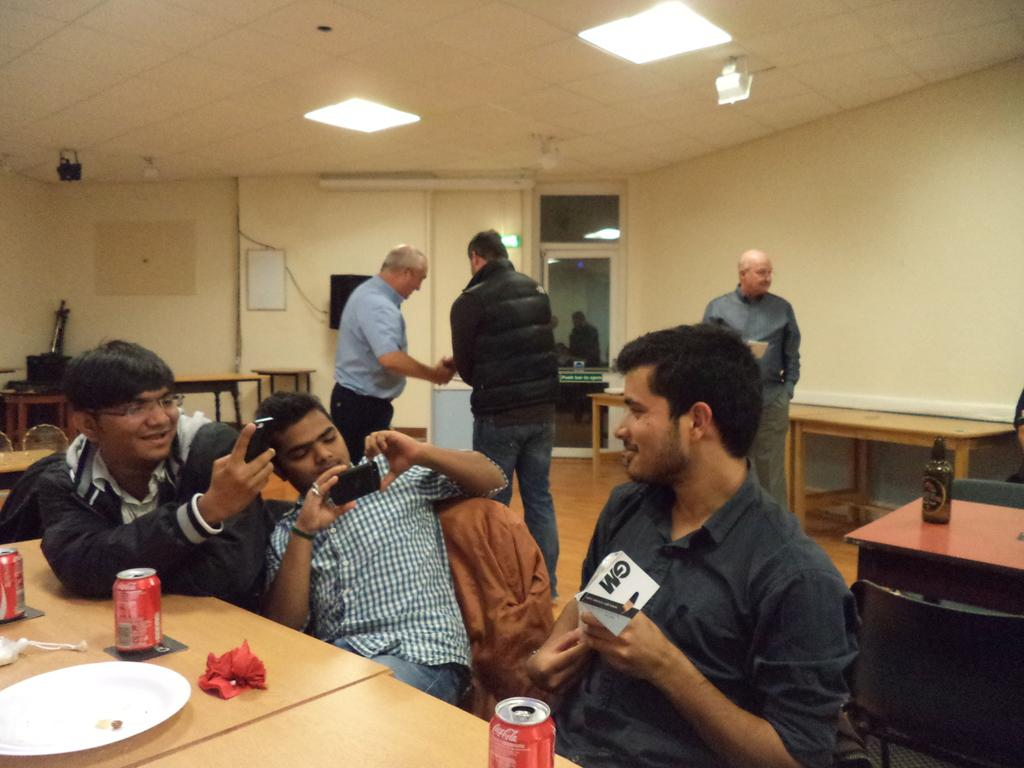How many people are in the image? There is a group of people in the image. What are the people in the image doing? The people are sitting. What is in front of the sitting people? There is a table in front of the people. What can be seen on the table? There is something written on the table, possibly a transcript. Are there any other people visible in the image? Yes, there are people standing in the background of the image. What type of yak can be seen wearing a vest in the image? There is no yak or vest present in the image. How much credit is available for the people in the image? The image does not provide information about credit or finances for the people. 